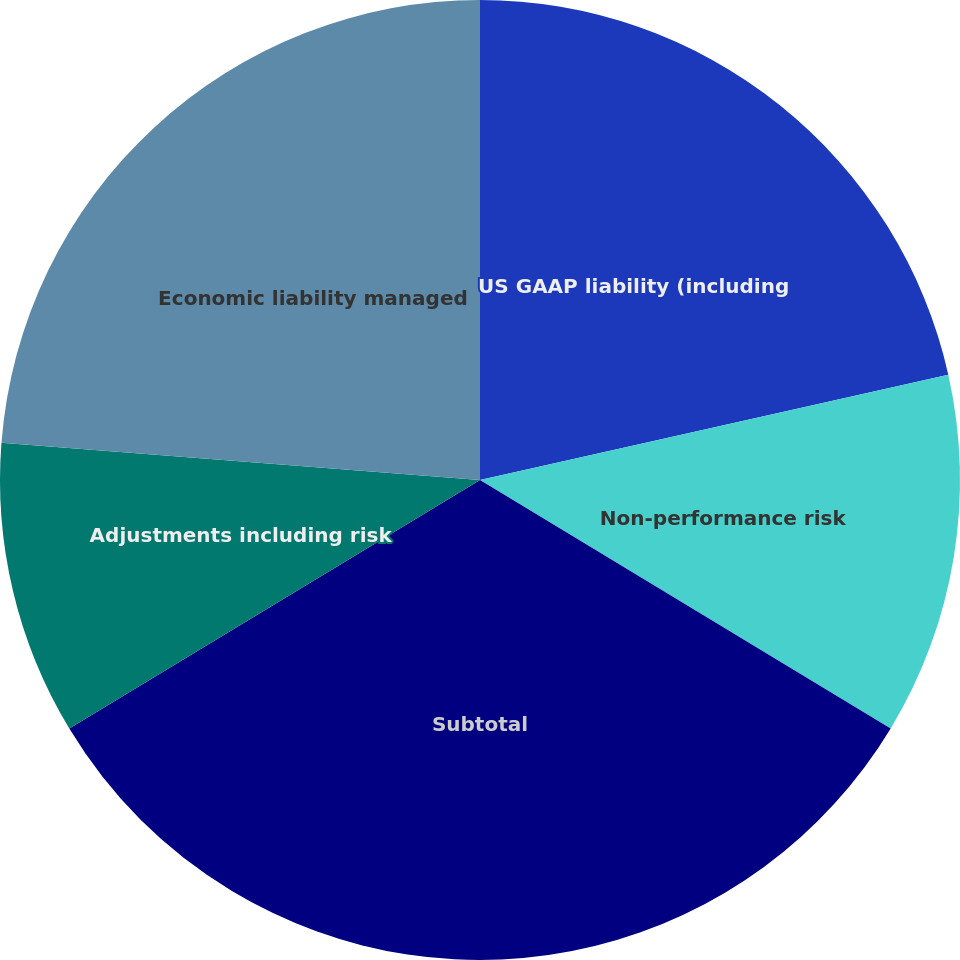Convert chart to OTSL. <chart><loc_0><loc_0><loc_500><loc_500><pie_chart><fcel>US GAAP liability (including<fcel>Non-performance risk<fcel>Subtotal<fcel>Adjustments including risk<fcel>Economic liability managed<nl><fcel>21.48%<fcel>12.18%<fcel>32.68%<fcel>9.9%<fcel>23.76%<nl></chart> 